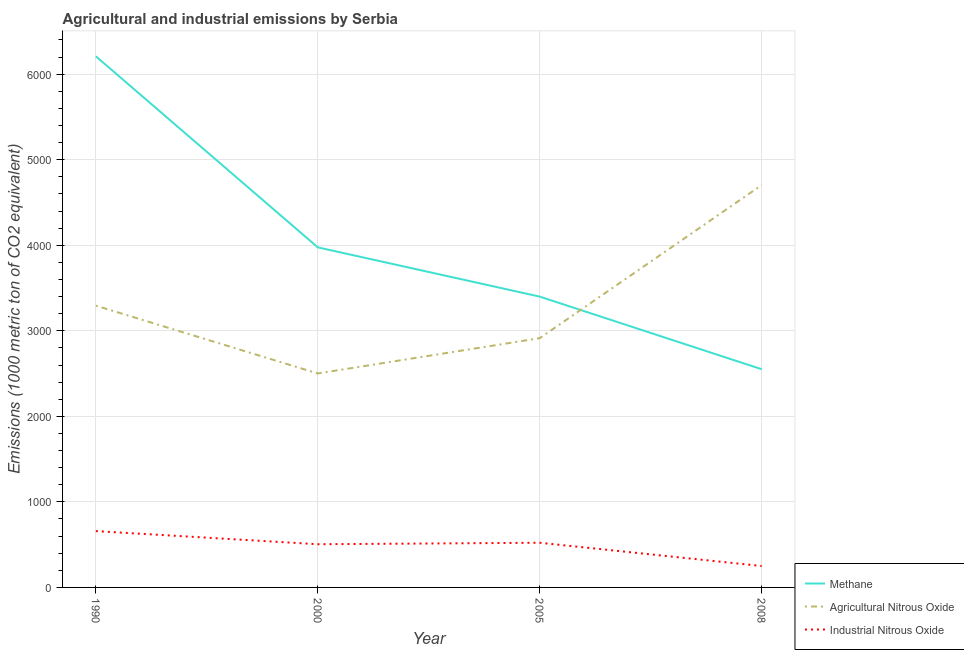What is the amount of agricultural nitrous oxide emissions in 1990?
Make the answer very short. 3293.8. Across all years, what is the maximum amount of methane emissions?
Ensure brevity in your answer.  6208.8. Across all years, what is the minimum amount of methane emissions?
Ensure brevity in your answer.  2550.7. What is the total amount of methane emissions in the graph?
Your answer should be compact. 1.61e+04. What is the difference between the amount of agricultural nitrous oxide emissions in 1990 and that in 2005?
Keep it short and to the point. 380. What is the difference between the amount of agricultural nitrous oxide emissions in 1990 and the amount of industrial nitrous oxide emissions in 2000?
Your response must be concise. 2788.8. What is the average amount of agricultural nitrous oxide emissions per year?
Offer a terse response. 3353.15. In the year 2000, what is the difference between the amount of methane emissions and amount of industrial nitrous oxide emissions?
Offer a terse response. 3470.3. In how many years, is the amount of methane emissions greater than 5000 metric ton?
Ensure brevity in your answer.  1. What is the ratio of the amount of industrial nitrous oxide emissions in 2000 to that in 2008?
Provide a succinct answer. 2.02. Is the amount of agricultural nitrous oxide emissions in 1990 less than that in 2005?
Offer a very short reply. No. What is the difference between the highest and the second highest amount of methane emissions?
Give a very brief answer. 2233.5. What is the difference between the highest and the lowest amount of methane emissions?
Your response must be concise. 3658.1. In how many years, is the amount of industrial nitrous oxide emissions greater than the average amount of industrial nitrous oxide emissions taken over all years?
Keep it short and to the point. 3. Is the sum of the amount of methane emissions in 2005 and 2008 greater than the maximum amount of agricultural nitrous oxide emissions across all years?
Your answer should be compact. Yes. Does the amount of industrial nitrous oxide emissions monotonically increase over the years?
Your answer should be very brief. No. Is the amount of methane emissions strictly greater than the amount of agricultural nitrous oxide emissions over the years?
Offer a terse response. No. Is the amount of methane emissions strictly less than the amount of agricultural nitrous oxide emissions over the years?
Give a very brief answer. No. How many years are there in the graph?
Your answer should be compact. 4. What is the difference between two consecutive major ticks on the Y-axis?
Your answer should be very brief. 1000. Does the graph contain any zero values?
Your answer should be compact. No. Does the graph contain grids?
Offer a very short reply. Yes. Where does the legend appear in the graph?
Keep it short and to the point. Bottom right. How are the legend labels stacked?
Offer a terse response. Vertical. What is the title of the graph?
Give a very brief answer. Agricultural and industrial emissions by Serbia. Does "Negligence towards kids" appear as one of the legend labels in the graph?
Your answer should be compact. No. What is the label or title of the Y-axis?
Offer a very short reply. Emissions (1000 metric ton of CO2 equivalent). What is the Emissions (1000 metric ton of CO2 equivalent) in Methane in 1990?
Offer a very short reply. 6208.8. What is the Emissions (1000 metric ton of CO2 equivalent) of Agricultural Nitrous Oxide in 1990?
Keep it short and to the point. 3293.8. What is the Emissions (1000 metric ton of CO2 equivalent) in Industrial Nitrous Oxide in 1990?
Your answer should be very brief. 658.4. What is the Emissions (1000 metric ton of CO2 equivalent) of Methane in 2000?
Provide a short and direct response. 3975.3. What is the Emissions (1000 metric ton of CO2 equivalent) of Agricultural Nitrous Oxide in 2000?
Your answer should be compact. 2501.4. What is the Emissions (1000 metric ton of CO2 equivalent) in Industrial Nitrous Oxide in 2000?
Provide a short and direct response. 505. What is the Emissions (1000 metric ton of CO2 equivalent) in Methane in 2005?
Provide a short and direct response. 3399.6. What is the Emissions (1000 metric ton of CO2 equivalent) in Agricultural Nitrous Oxide in 2005?
Your answer should be compact. 2913.8. What is the Emissions (1000 metric ton of CO2 equivalent) of Industrial Nitrous Oxide in 2005?
Offer a very short reply. 522.3. What is the Emissions (1000 metric ton of CO2 equivalent) of Methane in 2008?
Give a very brief answer. 2550.7. What is the Emissions (1000 metric ton of CO2 equivalent) of Agricultural Nitrous Oxide in 2008?
Make the answer very short. 4703.6. What is the Emissions (1000 metric ton of CO2 equivalent) of Industrial Nitrous Oxide in 2008?
Offer a terse response. 250.3. Across all years, what is the maximum Emissions (1000 metric ton of CO2 equivalent) in Methane?
Offer a very short reply. 6208.8. Across all years, what is the maximum Emissions (1000 metric ton of CO2 equivalent) in Agricultural Nitrous Oxide?
Make the answer very short. 4703.6. Across all years, what is the maximum Emissions (1000 metric ton of CO2 equivalent) in Industrial Nitrous Oxide?
Offer a very short reply. 658.4. Across all years, what is the minimum Emissions (1000 metric ton of CO2 equivalent) of Methane?
Offer a terse response. 2550.7. Across all years, what is the minimum Emissions (1000 metric ton of CO2 equivalent) in Agricultural Nitrous Oxide?
Your response must be concise. 2501.4. Across all years, what is the minimum Emissions (1000 metric ton of CO2 equivalent) of Industrial Nitrous Oxide?
Your answer should be very brief. 250.3. What is the total Emissions (1000 metric ton of CO2 equivalent) in Methane in the graph?
Make the answer very short. 1.61e+04. What is the total Emissions (1000 metric ton of CO2 equivalent) of Agricultural Nitrous Oxide in the graph?
Your response must be concise. 1.34e+04. What is the total Emissions (1000 metric ton of CO2 equivalent) in Industrial Nitrous Oxide in the graph?
Provide a succinct answer. 1936. What is the difference between the Emissions (1000 metric ton of CO2 equivalent) of Methane in 1990 and that in 2000?
Give a very brief answer. 2233.5. What is the difference between the Emissions (1000 metric ton of CO2 equivalent) in Agricultural Nitrous Oxide in 1990 and that in 2000?
Your response must be concise. 792.4. What is the difference between the Emissions (1000 metric ton of CO2 equivalent) of Industrial Nitrous Oxide in 1990 and that in 2000?
Keep it short and to the point. 153.4. What is the difference between the Emissions (1000 metric ton of CO2 equivalent) in Methane in 1990 and that in 2005?
Keep it short and to the point. 2809.2. What is the difference between the Emissions (1000 metric ton of CO2 equivalent) in Agricultural Nitrous Oxide in 1990 and that in 2005?
Offer a terse response. 380. What is the difference between the Emissions (1000 metric ton of CO2 equivalent) in Industrial Nitrous Oxide in 1990 and that in 2005?
Your answer should be very brief. 136.1. What is the difference between the Emissions (1000 metric ton of CO2 equivalent) of Methane in 1990 and that in 2008?
Provide a short and direct response. 3658.1. What is the difference between the Emissions (1000 metric ton of CO2 equivalent) in Agricultural Nitrous Oxide in 1990 and that in 2008?
Keep it short and to the point. -1409.8. What is the difference between the Emissions (1000 metric ton of CO2 equivalent) in Industrial Nitrous Oxide in 1990 and that in 2008?
Ensure brevity in your answer.  408.1. What is the difference between the Emissions (1000 metric ton of CO2 equivalent) in Methane in 2000 and that in 2005?
Provide a succinct answer. 575.7. What is the difference between the Emissions (1000 metric ton of CO2 equivalent) of Agricultural Nitrous Oxide in 2000 and that in 2005?
Offer a very short reply. -412.4. What is the difference between the Emissions (1000 metric ton of CO2 equivalent) in Industrial Nitrous Oxide in 2000 and that in 2005?
Your answer should be very brief. -17.3. What is the difference between the Emissions (1000 metric ton of CO2 equivalent) in Methane in 2000 and that in 2008?
Make the answer very short. 1424.6. What is the difference between the Emissions (1000 metric ton of CO2 equivalent) of Agricultural Nitrous Oxide in 2000 and that in 2008?
Make the answer very short. -2202.2. What is the difference between the Emissions (1000 metric ton of CO2 equivalent) in Industrial Nitrous Oxide in 2000 and that in 2008?
Keep it short and to the point. 254.7. What is the difference between the Emissions (1000 metric ton of CO2 equivalent) of Methane in 2005 and that in 2008?
Ensure brevity in your answer.  848.9. What is the difference between the Emissions (1000 metric ton of CO2 equivalent) of Agricultural Nitrous Oxide in 2005 and that in 2008?
Your answer should be compact. -1789.8. What is the difference between the Emissions (1000 metric ton of CO2 equivalent) in Industrial Nitrous Oxide in 2005 and that in 2008?
Make the answer very short. 272. What is the difference between the Emissions (1000 metric ton of CO2 equivalent) in Methane in 1990 and the Emissions (1000 metric ton of CO2 equivalent) in Agricultural Nitrous Oxide in 2000?
Your answer should be very brief. 3707.4. What is the difference between the Emissions (1000 metric ton of CO2 equivalent) of Methane in 1990 and the Emissions (1000 metric ton of CO2 equivalent) of Industrial Nitrous Oxide in 2000?
Give a very brief answer. 5703.8. What is the difference between the Emissions (1000 metric ton of CO2 equivalent) of Agricultural Nitrous Oxide in 1990 and the Emissions (1000 metric ton of CO2 equivalent) of Industrial Nitrous Oxide in 2000?
Your answer should be very brief. 2788.8. What is the difference between the Emissions (1000 metric ton of CO2 equivalent) of Methane in 1990 and the Emissions (1000 metric ton of CO2 equivalent) of Agricultural Nitrous Oxide in 2005?
Offer a very short reply. 3295. What is the difference between the Emissions (1000 metric ton of CO2 equivalent) of Methane in 1990 and the Emissions (1000 metric ton of CO2 equivalent) of Industrial Nitrous Oxide in 2005?
Your answer should be very brief. 5686.5. What is the difference between the Emissions (1000 metric ton of CO2 equivalent) in Agricultural Nitrous Oxide in 1990 and the Emissions (1000 metric ton of CO2 equivalent) in Industrial Nitrous Oxide in 2005?
Give a very brief answer. 2771.5. What is the difference between the Emissions (1000 metric ton of CO2 equivalent) of Methane in 1990 and the Emissions (1000 metric ton of CO2 equivalent) of Agricultural Nitrous Oxide in 2008?
Provide a short and direct response. 1505.2. What is the difference between the Emissions (1000 metric ton of CO2 equivalent) in Methane in 1990 and the Emissions (1000 metric ton of CO2 equivalent) in Industrial Nitrous Oxide in 2008?
Provide a succinct answer. 5958.5. What is the difference between the Emissions (1000 metric ton of CO2 equivalent) of Agricultural Nitrous Oxide in 1990 and the Emissions (1000 metric ton of CO2 equivalent) of Industrial Nitrous Oxide in 2008?
Provide a succinct answer. 3043.5. What is the difference between the Emissions (1000 metric ton of CO2 equivalent) in Methane in 2000 and the Emissions (1000 metric ton of CO2 equivalent) in Agricultural Nitrous Oxide in 2005?
Your response must be concise. 1061.5. What is the difference between the Emissions (1000 metric ton of CO2 equivalent) of Methane in 2000 and the Emissions (1000 metric ton of CO2 equivalent) of Industrial Nitrous Oxide in 2005?
Your response must be concise. 3453. What is the difference between the Emissions (1000 metric ton of CO2 equivalent) of Agricultural Nitrous Oxide in 2000 and the Emissions (1000 metric ton of CO2 equivalent) of Industrial Nitrous Oxide in 2005?
Ensure brevity in your answer.  1979.1. What is the difference between the Emissions (1000 metric ton of CO2 equivalent) in Methane in 2000 and the Emissions (1000 metric ton of CO2 equivalent) in Agricultural Nitrous Oxide in 2008?
Keep it short and to the point. -728.3. What is the difference between the Emissions (1000 metric ton of CO2 equivalent) in Methane in 2000 and the Emissions (1000 metric ton of CO2 equivalent) in Industrial Nitrous Oxide in 2008?
Offer a terse response. 3725. What is the difference between the Emissions (1000 metric ton of CO2 equivalent) in Agricultural Nitrous Oxide in 2000 and the Emissions (1000 metric ton of CO2 equivalent) in Industrial Nitrous Oxide in 2008?
Your response must be concise. 2251.1. What is the difference between the Emissions (1000 metric ton of CO2 equivalent) in Methane in 2005 and the Emissions (1000 metric ton of CO2 equivalent) in Agricultural Nitrous Oxide in 2008?
Ensure brevity in your answer.  -1304. What is the difference between the Emissions (1000 metric ton of CO2 equivalent) of Methane in 2005 and the Emissions (1000 metric ton of CO2 equivalent) of Industrial Nitrous Oxide in 2008?
Keep it short and to the point. 3149.3. What is the difference between the Emissions (1000 metric ton of CO2 equivalent) of Agricultural Nitrous Oxide in 2005 and the Emissions (1000 metric ton of CO2 equivalent) of Industrial Nitrous Oxide in 2008?
Ensure brevity in your answer.  2663.5. What is the average Emissions (1000 metric ton of CO2 equivalent) in Methane per year?
Provide a succinct answer. 4033.6. What is the average Emissions (1000 metric ton of CO2 equivalent) in Agricultural Nitrous Oxide per year?
Ensure brevity in your answer.  3353.15. What is the average Emissions (1000 metric ton of CO2 equivalent) in Industrial Nitrous Oxide per year?
Your response must be concise. 484. In the year 1990, what is the difference between the Emissions (1000 metric ton of CO2 equivalent) in Methane and Emissions (1000 metric ton of CO2 equivalent) in Agricultural Nitrous Oxide?
Offer a terse response. 2915. In the year 1990, what is the difference between the Emissions (1000 metric ton of CO2 equivalent) in Methane and Emissions (1000 metric ton of CO2 equivalent) in Industrial Nitrous Oxide?
Offer a very short reply. 5550.4. In the year 1990, what is the difference between the Emissions (1000 metric ton of CO2 equivalent) of Agricultural Nitrous Oxide and Emissions (1000 metric ton of CO2 equivalent) of Industrial Nitrous Oxide?
Provide a succinct answer. 2635.4. In the year 2000, what is the difference between the Emissions (1000 metric ton of CO2 equivalent) of Methane and Emissions (1000 metric ton of CO2 equivalent) of Agricultural Nitrous Oxide?
Your answer should be very brief. 1473.9. In the year 2000, what is the difference between the Emissions (1000 metric ton of CO2 equivalent) in Methane and Emissions (1000 metric ton of CO2 equivalent) in Industrial Nitrous Oxide?
Your answer should be very brief. 3470.3. In the year 2000, what is the difference between the Emissions (1000 metric ton of CO2 equivalent) of Agricultural Nitrous Oxide and Emissions (1000 metric ton of CO2 equivalent) of Industrial Nitrous Oxide?
Keep it short and to the point. 1996.4. In the year 2005, what is the difference between the Emissions (1000 metric ton of CO2 equivalent) of Methane and Emissions (1000 metric ton of CO2 equivalent) of Agricultural Nitrous Oxide?
Offer a terse response. 485.8. In the year 2005, what is the difference between the Emissions (1000 metric ton of CO2 equivalent) in Methane and Emissions (1000 metric ton of CO2 equivalent) in Industrial Nitrous Oxide?
Provide a succinct answer. 2877.3. In the year 2005, what is the difference between the Emissions (1000 metric ton of CO2 equivalent) in Agricultural Nitrous Oxide and Emissions (1000 metric ton of CO2 equivalent) in Industrial Nitrous Oxide?
Make the answer very short. 2391.5. In the year 2008, what is the difference between the Emissions (1000 metric ton of CO2 equivalent) of Methane and Emissions (1000 metric ton of CO2 equivalent) of Agricultural Nitrous Oxide?
Offer a terse response. -2152.9. In the year 2008, what is the difference between the Emissions (1000 metric ton of CO2 equivalent) of Methane and Emissions (1000 metric ton of CO2 equivalent) of Industrial Nitrous Oxide?
Your response must be concise. 2300.4. In the year 2008, what is the difference between the Emissions (1000 metric ton of CO2 equivalent) in Agricultural Nitrous Oxide and Emissions (1000 metric ton of CO2 equivalent) in Industrial Nitrous Oxide?
Make the answer very short. 4453.3. What is the ratio of the Emissions (1000 metric ton of CO2 equivalent) of Methane in 1990 to that in 2000?
Offer a terse response. 1.56. What is the ratio of the Emissions (1000 metric ton of CO2 equivalent) in Agricultural Nitrous Oxide in 1990 to that in 2000?
Provide a succinct answer. 1.32. What is the ratio of the Emissions (1000 metric ton of CO2 equivalent) in Industrial Nitrous Oxide in 1990 to that in 2000?
Provide a short and direct response. 1.3. What is the ratio of the Emissions (1000 metric ton of CO2 equivalent) in Methane in 1990 to that in 2005?
Provide a succinct answer. 1.83. What is the ratio of the Emissions (1000 metric ton of CO2 equivalent) of Agricultural Nitrous Oxide in 1990 to that in 2005?
Provide a succinct answer. 1.13. What is the ratio of the Emissions (1000 metric ton of CO2 equivalent) of Industrial Nitrous Oxide in 1990 to that in 2005?
Your response must be concise. 1.26. What is the ratio of the Emissions (1000 metric ton of CO2 equivalent) in Methane in 1990 to that in 2008?
Keep it short and to the point. 2.43. What is the ratio of the Emissions (1000 metric ton of CO2 equivalent) of Agricultural Nitrous Oxide in 1990 to that in 2008?
Provide a succinct answer. 0.7. What is the ratio of the Emissions (1000 metric ton of CO2 equivalent) in Industrial Nitrous Oxide in 1990 to that in 2008?
Your answer should be compact. 2.63. What is the ratio of the Emissions (1000 metric ton of CO2 equivalent) of Methane in 2000 to that in 2005?
Make the answer very short. 1.17. What is the ratio of the Emissions (1000 metric ton of CO2 equivalent) in Agricultural Nitrous Oxide in 2000 to that in 2005?
Ensure brevity in your answer.  0.86. What is the ratio of the Emissions (1000 metric ton of CO2 equivalent) of Industrial Nitrous Oxide in 2000 to that in 2005?
Make the answer very short. 0.97. What is the ratio of the Emissions (1000 metric ton of CO2 equivalent) in Methane in 2000 to that in 2008?
Offer a very short reply. 1.56. What is the ratio of the Emissions (1000 metric ton of CO2 equivalent) of Agricultural Nitrous Oxide in 2000 to that in 2008?
Your answer should be very brief. 0.53. What is the ratio of the Emissions (1000 metric ton of CO2 equivalent) of Industrial Nitrous Oxide in 2000 to that in 2008?
Make the answer very short. 2.02. What is the ratio of the Emissions (1000 metric ton of CO2 equivalent) in Methane in 2005 to that in 2008?
Provide a succinct answer. 1.33. What is the ratio of the Emissions (1000 metric ton of CO2 equivalent) of Agricultural Nitrous Oxide in 2005 to that in 2008?
Your response must be concise. 0.62. What is the ratio of the Emissions (1000 metric ton of CO2 equivalent) of Industrial Nitrous Oxide in 2005 to that in 2008?
Your answer should be compact. 2.09. What is the difference between the highest and the second highest Emissions (1000 metric ton of CO2 equivalent) of Methane?
Keep it short and to the point. 2233.5. What is the difference between the highest and the second highest Emissions (1000 metric ton of CO2 equivalent) of Agricultural Nitrous Oxide?
Offer a very short reply. 1409.8. What is the difference between the highest and the second highest Emissions (1000 metric ton of CO2 equivalent) of Industrial Nitrous Oxide?
Your response must be concise. 136.1. What is the difference between the highest and the lowest Emissions (1000 metric ton of CO2 equivalent) in Methane?
Provide a short and direct response. 3658.1. What is the difference between the highest and the lowest Emissions (1000 metric ton of CO2 equivalent) in Agricultural Nitrous Oxide?
Ensure brevity in your answer.  2202.2. What is the difference between the highest and the lowest Emissions (1000 metric ton of CO2 equivalent) in Industrial Nitrous Oxide?
Keep it short and to the point. 408.1. 